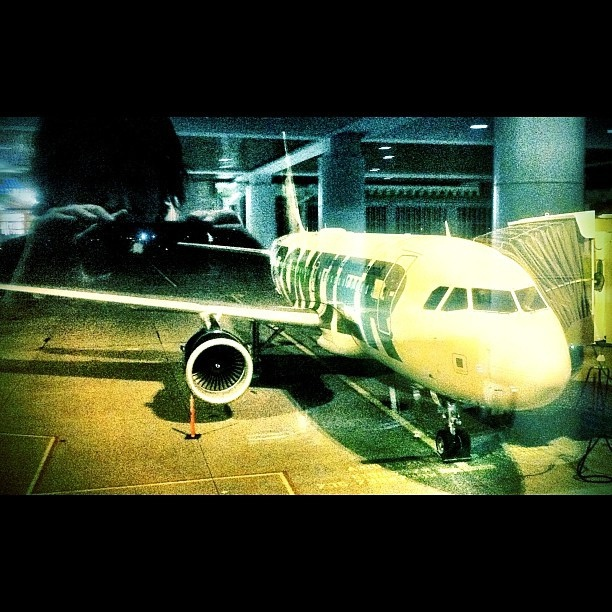Describe the objects in this image and their specific colors. I can see airplane in black, lightyellow, and khaki tones and people in black, teal, and ivory tones in this image. 